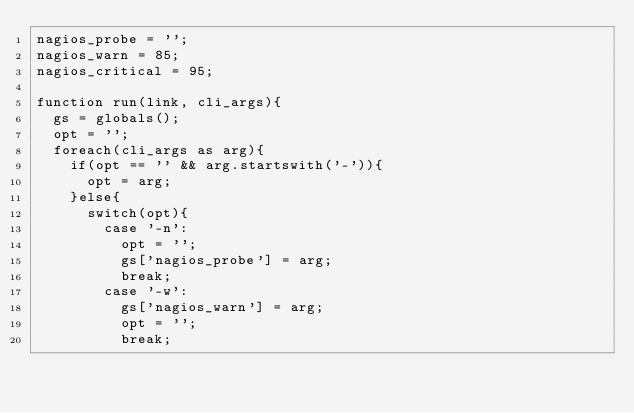<code> <loc_0><loc_0><loc_500><loc_500><_COBOL_>nagios_probe = '';
nagios_warn = 85;
nagios_critical = 95;

function run(link, cli_args){
	gs = globals();
	opt = '';
	foreach(cli_args as arg){
		if(opt == '' && arg.startswith('-')){
			opt = arg;
		}else{
			switch(opt){
				case '-n':
					opt = '';
					gs['nagios_probe'] = arg;
					break;
				case '-w':
					gs['nagios_warn'] = arg;
					opt = '';
					break;</code> 